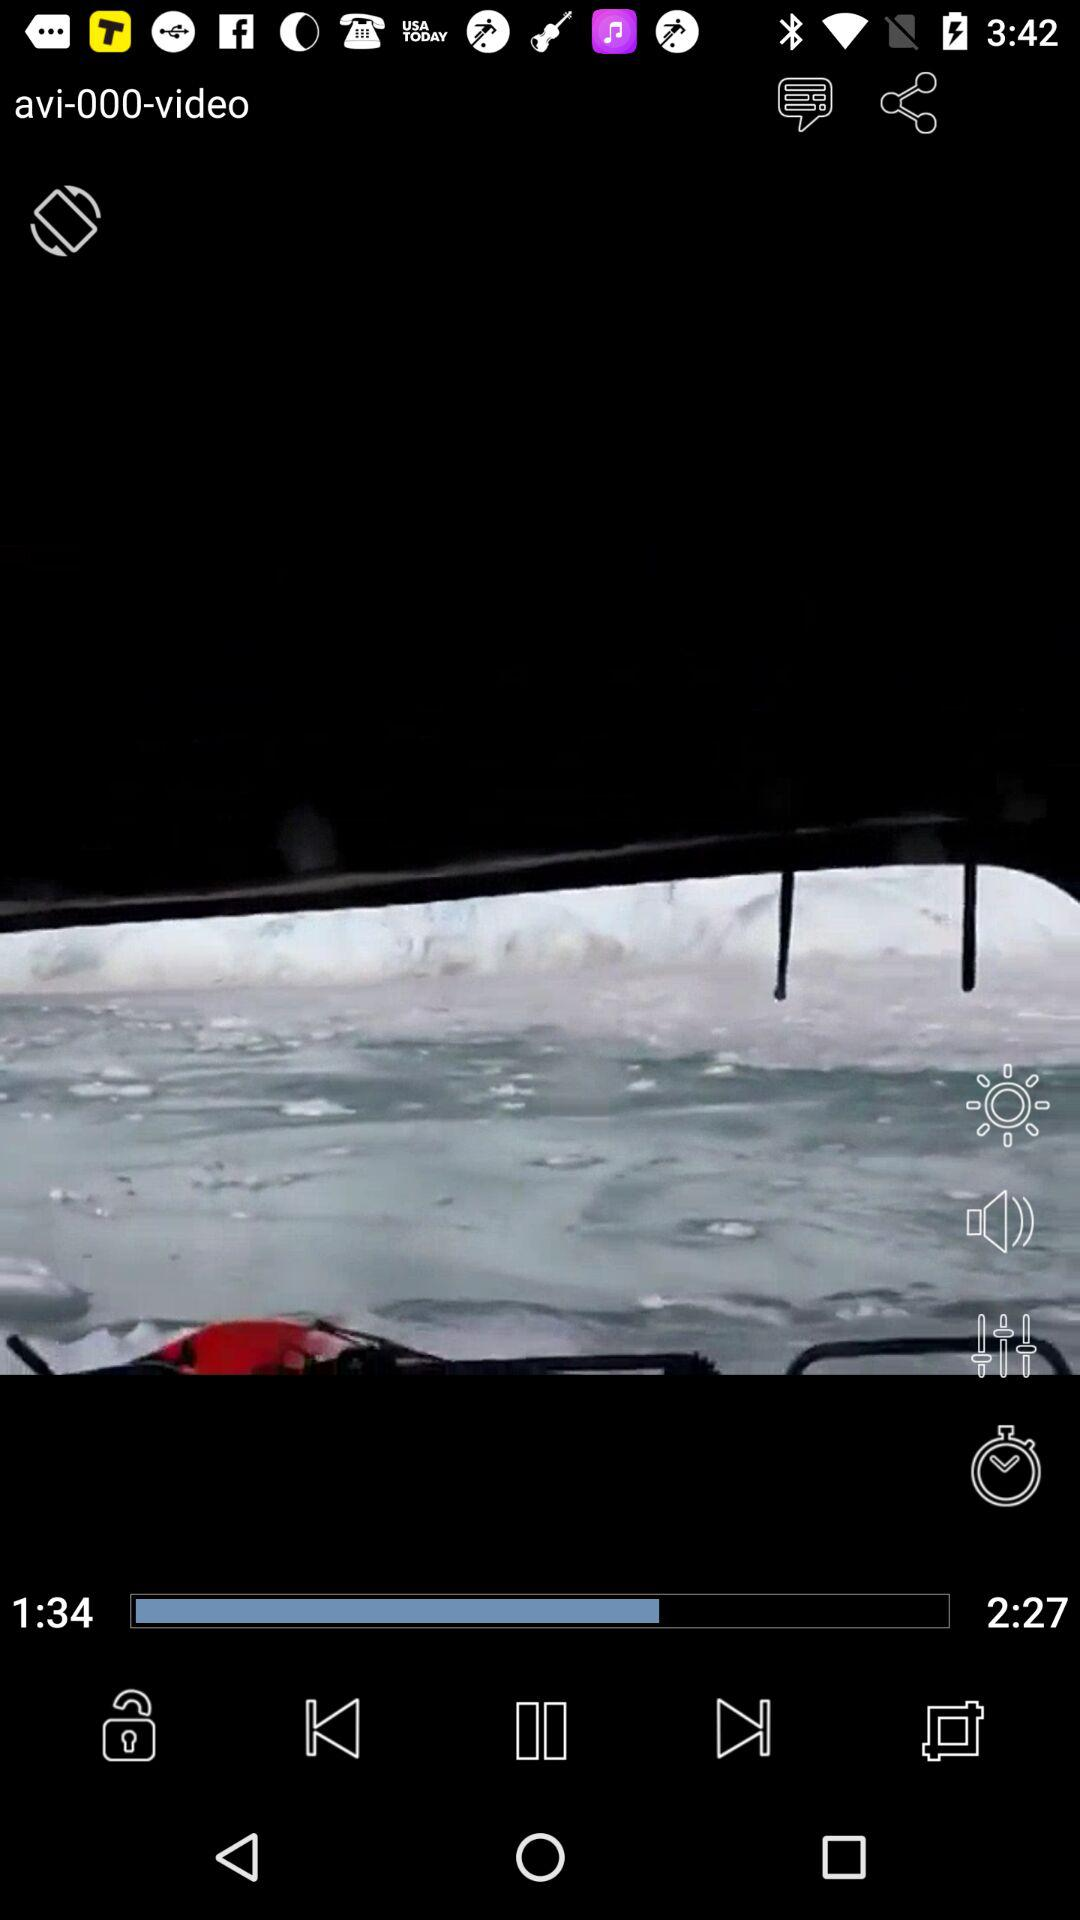How many seconds longer is the video length than the playing time?
Answer the question using a single word or phrase. 53 